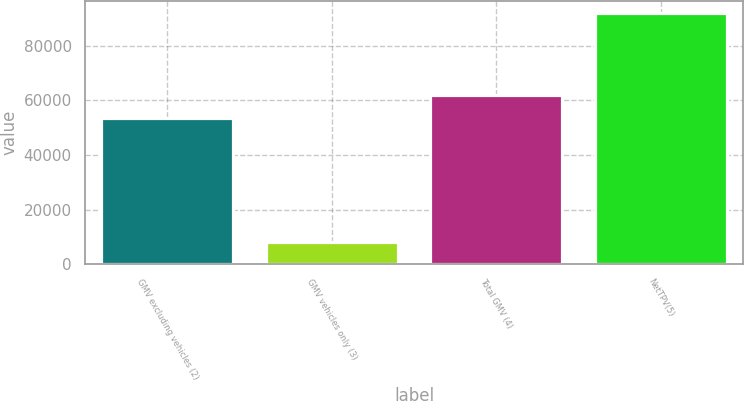Convert chart. <chart><loc_0><loc_0><loc_500><loc_500><bar_chart><fcel>GMV excluding vehicles (2)<fcel>GMV vehicles only (3)<fcel>Total GMV (4)<fcel>NetTPV(5)<nl><fcel>53532<fcel>8287<fcel>61898.9<fcel>91956<nl></chart> 